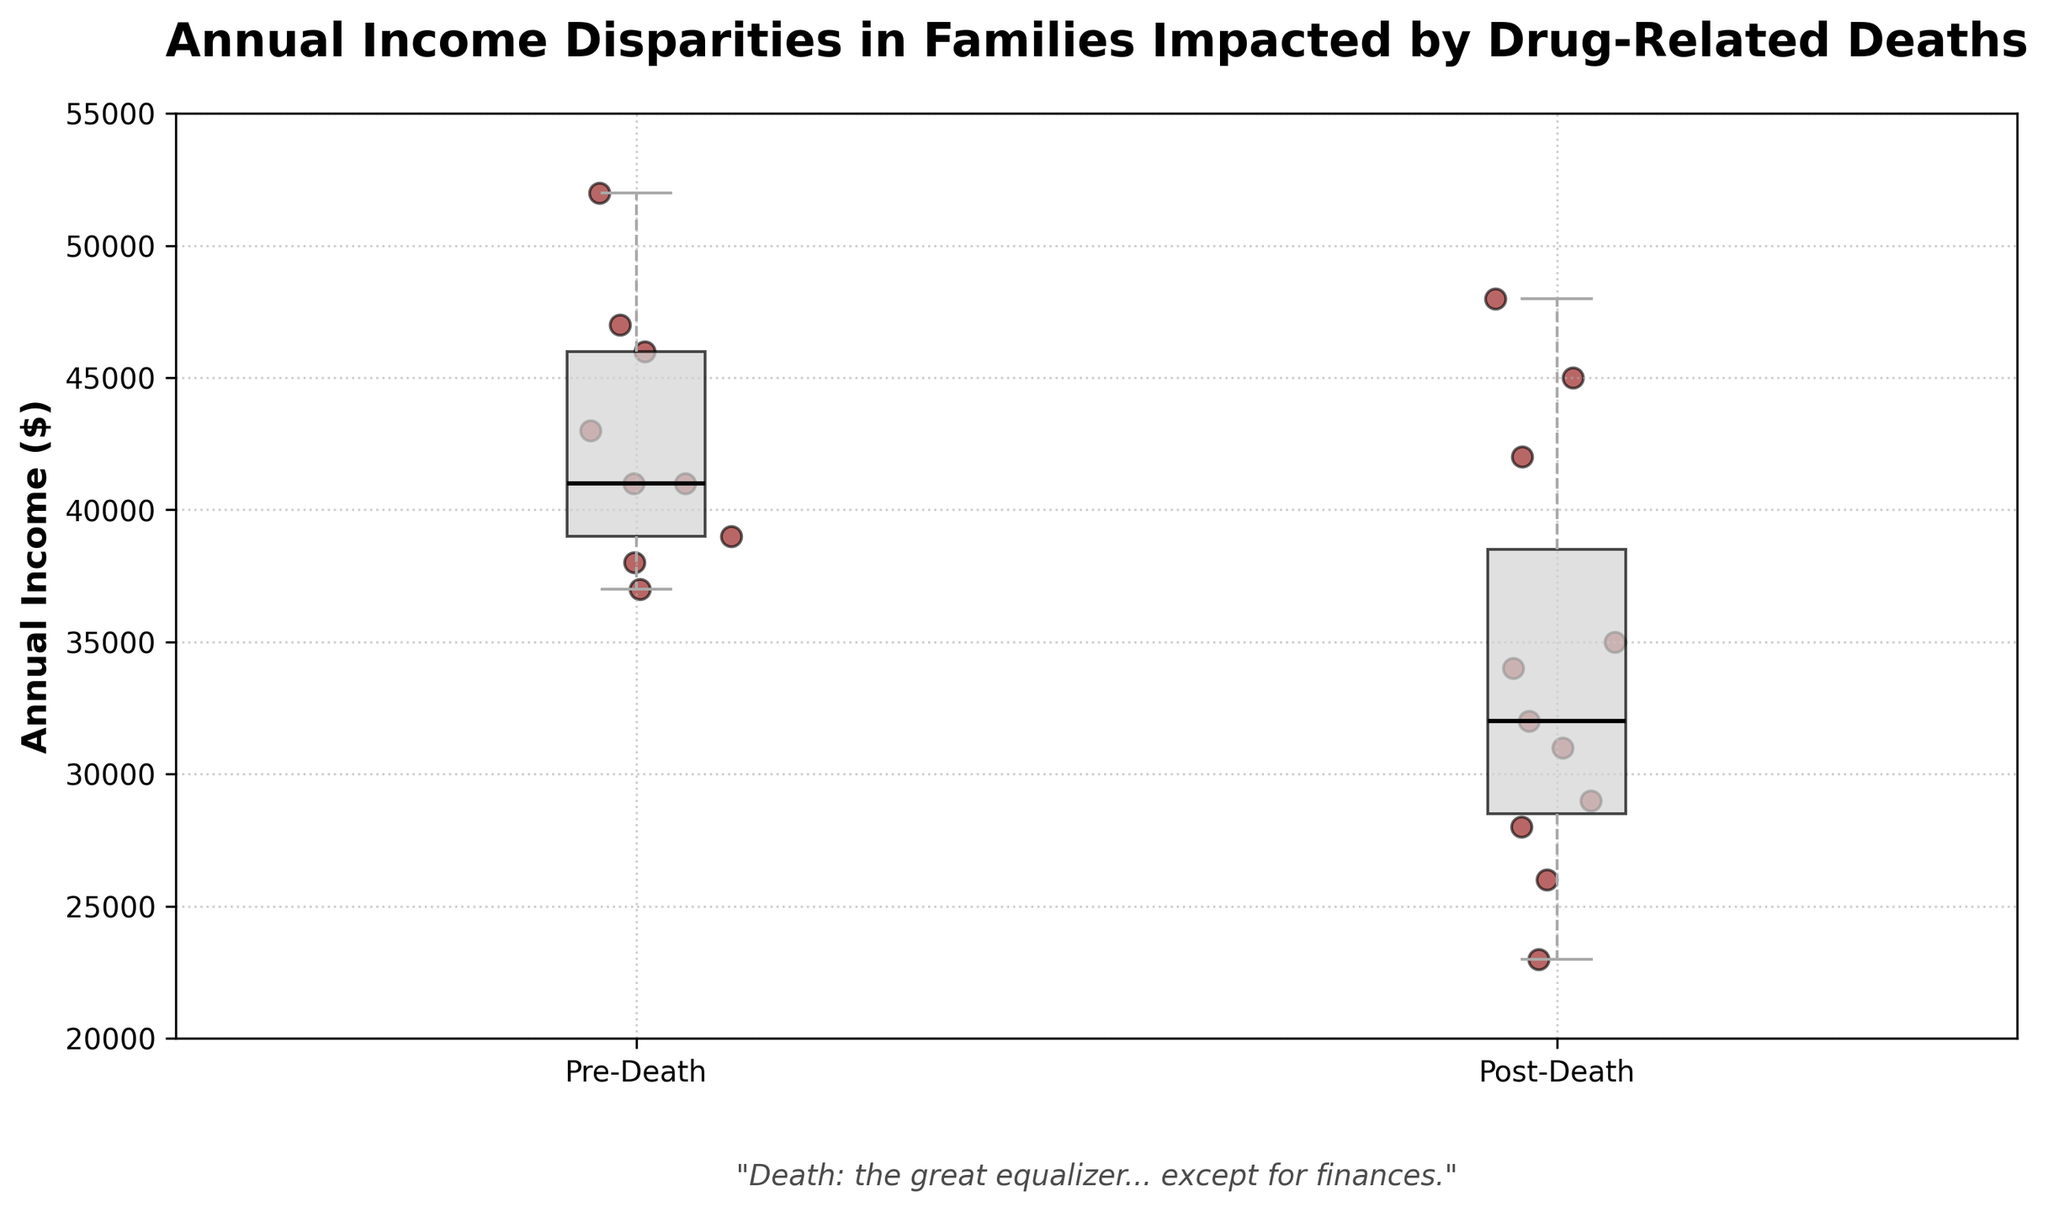What's the title of the figure? The title of the figure can be found at the top of the plot, which usually states what the plot represents.
Answer: Annual Income Disparities in Families Impacted by Drug-Related Deaths What does the median line represent in the box plot? The median line in a box plot represents the middle value of the data set, which divides the data into two equal halves.
Answer: The middle value What is the median annual income for the "Post-Death" group? The black median line inside the box for the "Post-Death" group shows the median value of that group's annual income.
Answer: Approximately $34000 Is the median annual income higher in the "Pre-Death" or "Post-Death" group? By comparing the median lines (the middle horizontal lines) within the boxes, you can see which box has a higher median.
Answer: Pre-Death How does the range of incomes in the "Post-Death" group compare to the "Pre-Death" group? By looking at the length of the boxes and whiskers, you can determine the range of incomes for both groups. The longer the whiskers, the larger the range.
Answer: Post-Death has a wider range Which group shows more income variability? Variability in a box plot is indicated by the spread of the box and the length of the whiskers. The group with the wider box and longer whiskers shows more variability.
Answer: Post-Death What is the lowest annual income in the "Post-Death" group? The lowest annual income is indicated by the bottom whisker of the "Post-Death" box plot.
Answer: $23000 What is the highest annual income in the "Pre-Death" group? The highest annual income is shown by the top whisker of the "Pre-Death" box plot.
Answer: $52000 How many scatter points are there for the "Pre-Death" group? The scatter points can be counted by visually counting the points plotted around the "Pre-Death" box plot.
Answer: 9 points What is the irony in the quote provided in the figure? The quote suggests that while death is an equalizer in many respects, it ironically doesn't equalize financial disparities, which is illustrated by the income differences shown in the plot.
Answer: Death doesn't equalize finances 